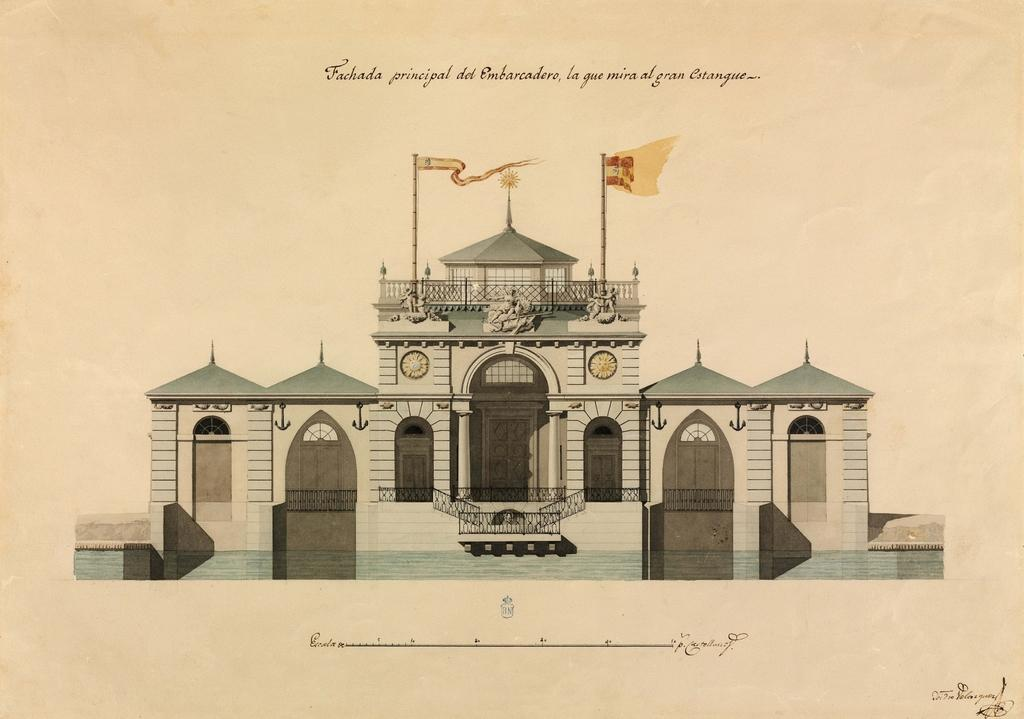What is the main object in the image? There is a paper in the image. What is depicted on the paper? There is a picture of a building printed on the paper. Are there any words or letters on the paper? Yes, there is text on the paper. What level of difficulty is the country depicted in the image? There is no country depicted in the image, only a picture of a building. How is the measure of the paper determined in the image? The size or measure of the paper is not mentioned in the image, so it cannot be determined from the image. 